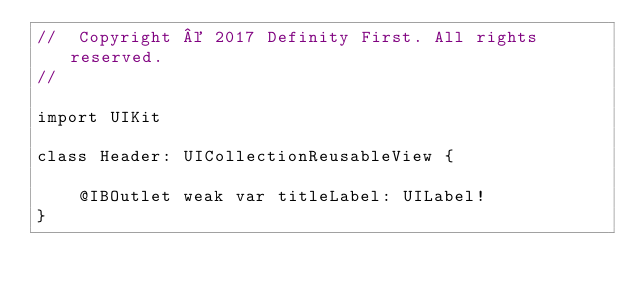<code> <loc_0><loc_0><loc_500><loc_500><_Swift_>//  Copyright © 2017 Definity First. All rights reserved.
//

import UIKit

class Header: UICollectionReusableView {

    @IBOutlet weak var titleLabel: UILabel!
}
</code> 